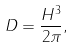<formula> <loc_0><loc_0><loc_500><loc_500>D = \frac { H ^ { 3 } } { 2 \pi } ,</formula> 